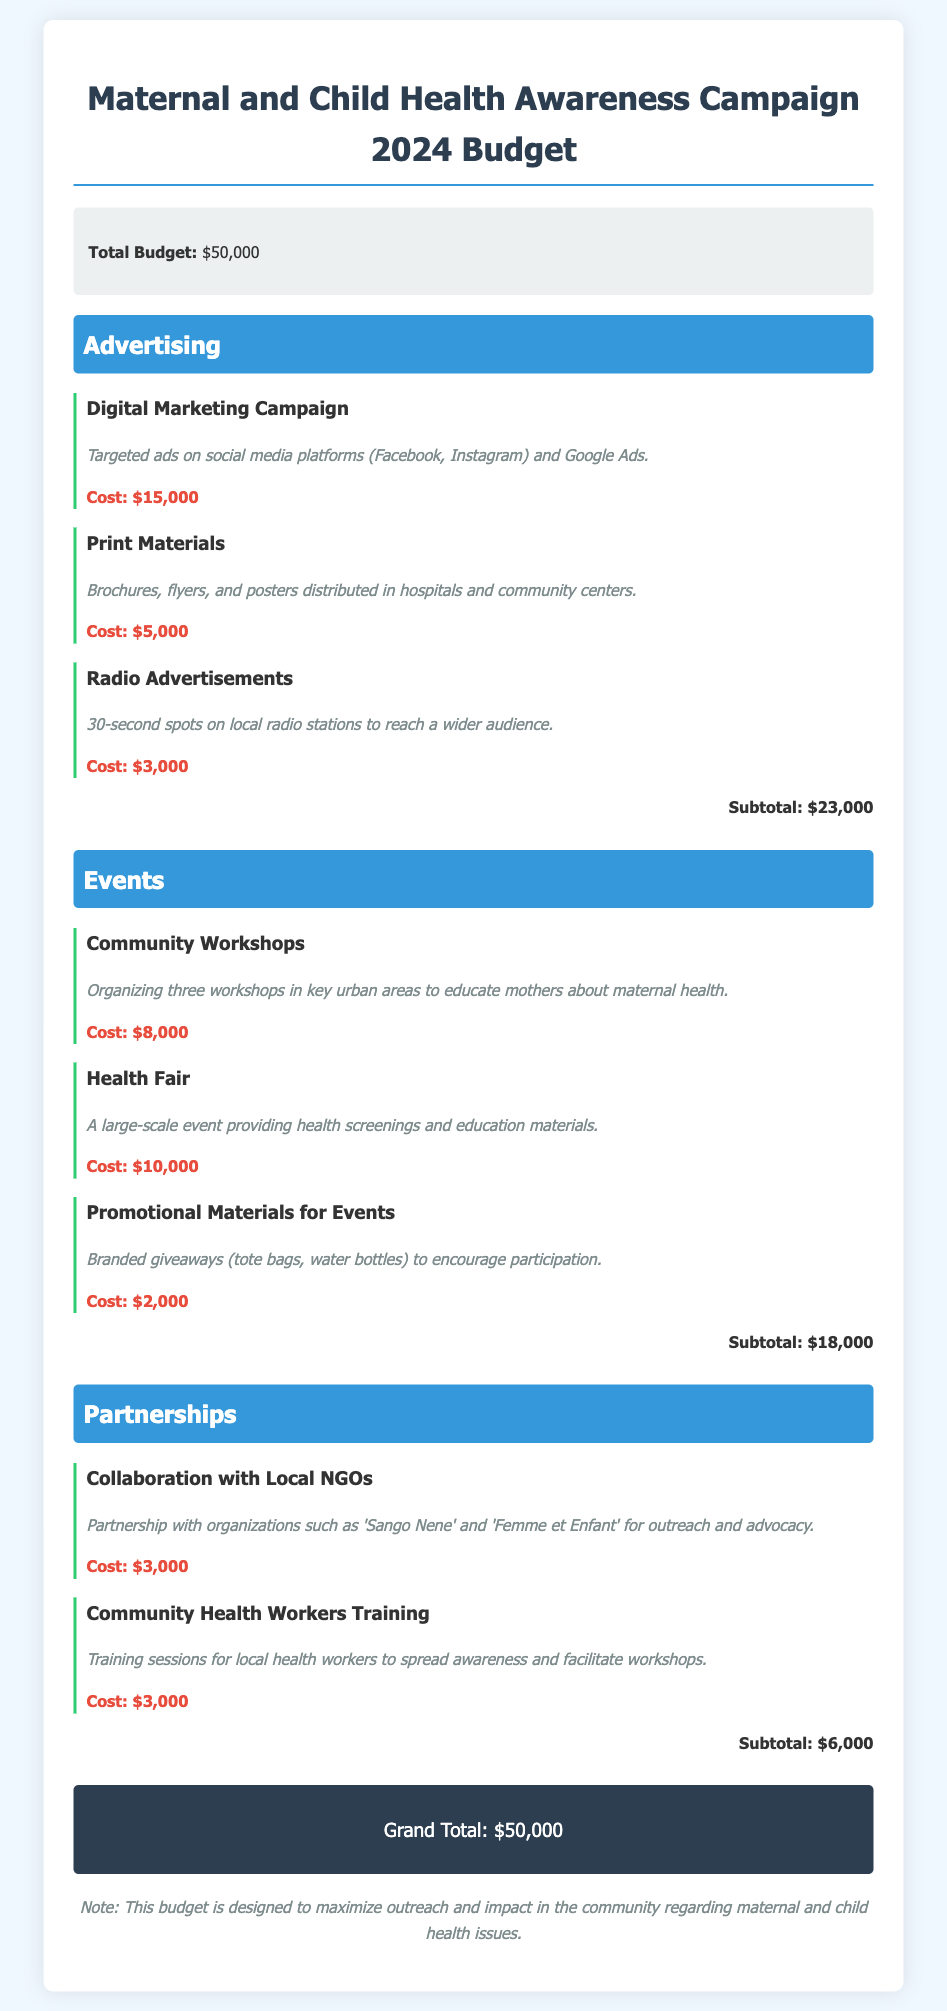What is the total budget? The total budget is specified at the beginning of the document in the budget summary section.
Answer: $50,000 How much is allocated for digital marketing? The allocation for the digital marketing campaign is listed under the advertising category.
Answer: $15,000 What type of event is planned with a cost of $10,000? The event with a cost of $10,000 is detailed in the events category.
Answer: Health Fair Which organizations are mentioned for partnerships? The partnerships include the organizations listed in the partnerships category.
Answer: Sango Nene and Femme et Enfant What is the subtotal for the advertising category? The subtotal for the advertising category is calculated by summing all expenses listed under that category.
Answer: $23,000 How many community workshops are organized? The number of community workshops is mentioned in the expense item description in the events category.
Answer: Three What is the cost for promotional materials for events? The cost for promotional materials is specified in the events category under the specific expense item.
Answer: $2,000 What is the total cost for partnerships? The total cost for partnerships is the sum of all expenses listed in that category.
Answer: $6,000 What style is used for the expense costs in the document? The specific styling for expense costs is distinctive and highlighted in the expense item entries.
Answer: Bold and red 